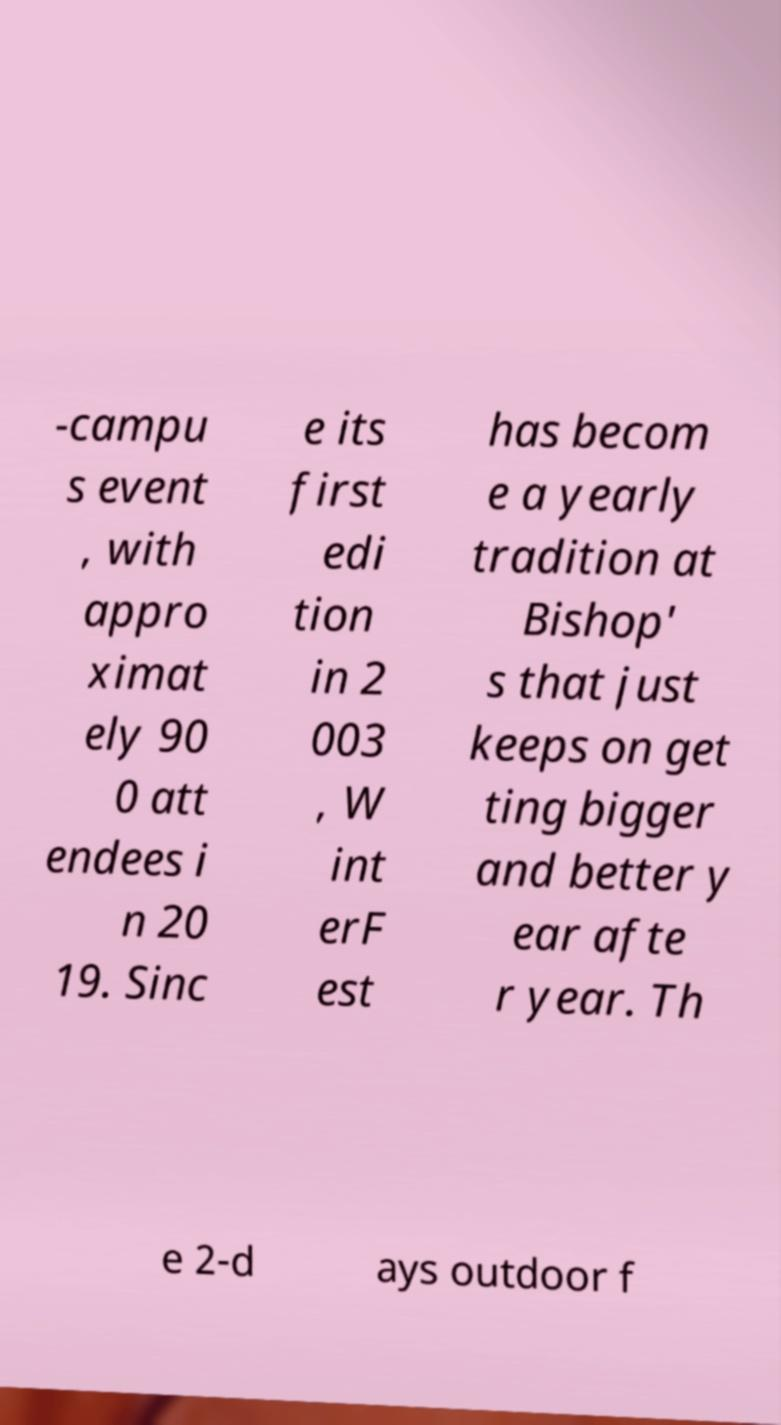I need the written content from this picture converted into text. Can you do that? -campu s event , with appro ximat ely 90 0 att endees i n 20 19. Sinc e its first edi tion in 2 003 , W int erF est has becom e a yearly tradition at Bishop' s that just keeps on get ting bigger and better y ear afte r year. Th e 2-d ays outdoor f 